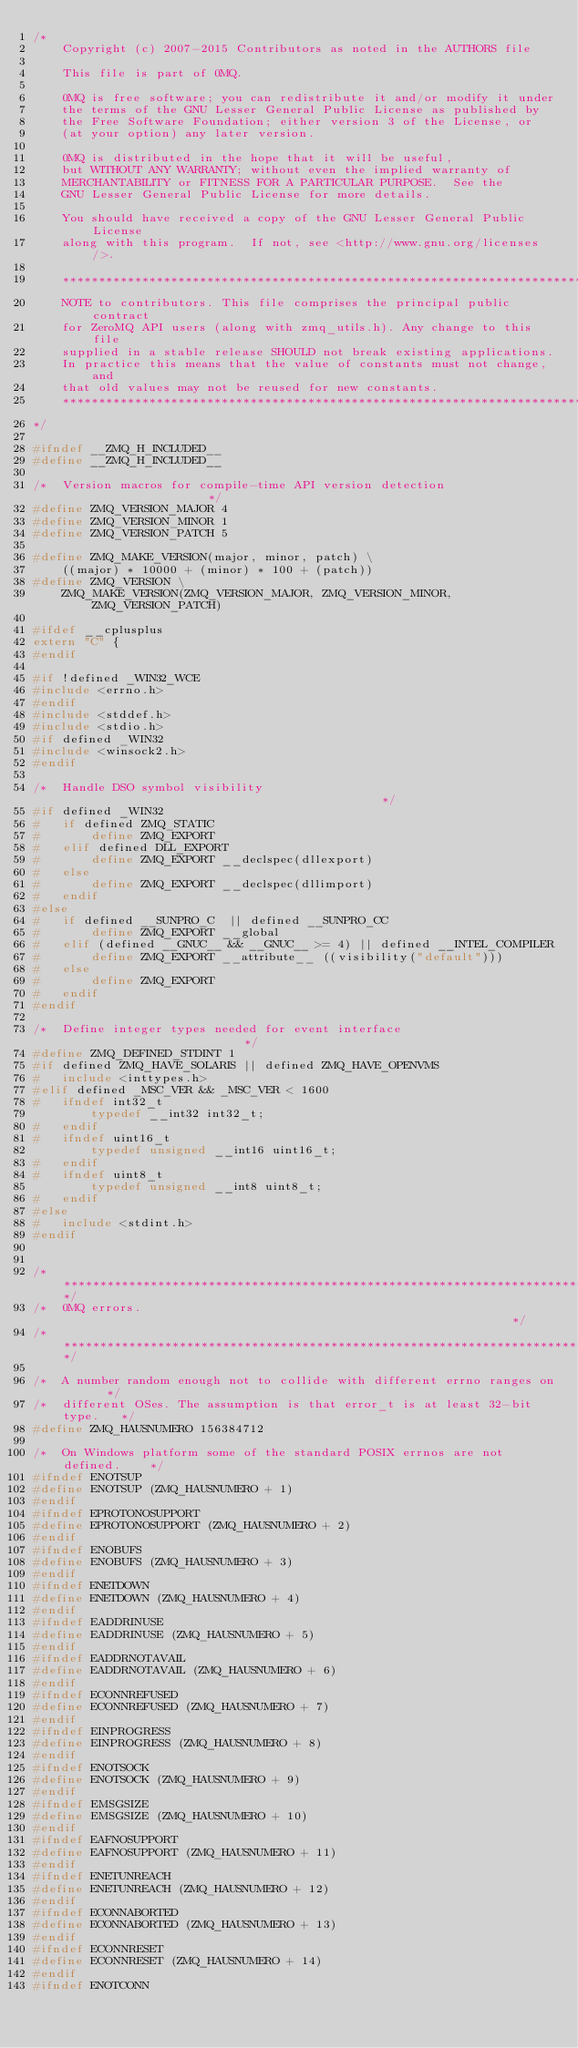Convert code to text. <code><loc_0><loc_0><loc_500><loc_500><_C_>/*
    Copyright (c) 2007-2015 Contributors as noted in the AUTHORS file

    This file is part of 0MQ.

    0MQ is free software; you can redistribute it and/or modify it under
    the terms of the GNU Lesser General Public License as published by
    the Free Software Foundation; either version 3 of the License, or
    (at your option) any later version.

    0MQ is distributed in the hope that it will be useful,
    but WITHOUT ANY WARRANTY; without even the implied warranty of
    MERCHANTABILITY or FITNESS FOR A PARTICULAR PURPOSE.  See the
    GNU Lesser General Public License for more details.

    You should have received a copy of the GNU Lesser General Public License
    along with this program.  If not, see <http://www.gnu.org/licenses/>.

    *************************************************************************
    NOTE to contributors. This file comprises the principal public contract
    for ZeroMQ API users (along with zmq_utils.h). Any change to this file
    supplied in a stable release SHOULD not break existing applications.
    In practice this means that the value of constants must not change, and
    that old values may not be reused for new constants.
    *************************************************************************
*/

#ifndef __ZMQ_H_INCLUDED__
#define __ZMQ_H_INCLUDED__

/*  Version macros for compile-time API version detection                     */
#define ZMQ_VERSION_MAJOR 4
#define ZMQ_VERSION_MINOR 1
#define ZMQ_VERSION_PATCH 5

#define ZMQ_MAKE_VERSION(major, minor, patch) \
    ((major) * 10000 + (minor) * 100 + (patch))
#define ZMQ_VERSION \
    ZMQ_MAKE_VERSION(ZMQ_VERSION_MAJOR, ZMQ_VERSION_MINOR, ZMQ_VERSION_PATCH)

#ifdef __cplusplus
extern "C" {
#endif

#if !defined _WIN32_WCE
#include <errno.h>
#endif
#include <stddef.h>
#include <stdio.h>
#if defined _WIN32
#include <winsock2.h>
#endif

/*  Handle DSO symbol visibility                                             */
#if defined _WIN32
#   if defined ZMQ_STATIC
#       define ZMQ_EXPORT
#   elif defined DLL_EXPORT
#       define ZMQ_EXPORT __declspec(dllexport)
#   else
#       define ZMQ_EXPORT __declspec(dllimport)
#   endif
#else
#   if defined __SUNPRO_C  || defined __SUNPRO_CC
#       define ZMQ_EXPORT __global
#   elif (defined __GNUC__ && __GNUC__ >= 4) || defined __INTEL_COMPILER
#       define ZMQ_EXPORT __attribute__ ((visibility("default")))
#   else
#       define ZMQ_EXPORT
#   endif
#endif

/*  Define integer types needed for event interface                          */
#define ZMQ_DEFINED_STDINT 1
#if defined ZMQ_HAVE_SOLARIS || defined ZMQ_HAVE_OPENVMS
#   include <inttypes.h>
#elif defined _MSC_VER && _MSC_VER < 1600
#   ifndef int32_t
        typedef __int32 int32_t;
#   endif
#   ifndef uint16_t
        typedef unsigned __int16 uint16_t;
#   endif
#   ifndef uint8_t
        typedef unsigned __int8 uint8_t;
#   endif
#else
#   include <stdint.h>
#endif


/******************************************************************************/
/*  0MQ errors.                                                               */
/******************************************************************************/

/*  A number random enough not to collide with different errno ranges on      */
/*  different OSes. The assumption is that error_t is at least 32-bit type.   */
#define ZMQ_HAUSNUMERO 156384712

/*  On Windows platform some of the standard POSIX errnos are not defined.    */
#ifndef ENOTSUP
#define ENOTSUP (ZMQ_HAUSNUMERO + 1)
#endif
#ifndef EPROTONOSUPPORT
#define EPROTONOSUPPORT (ZMQ_HAUSNUMERO + 2)
#endif
#ifndef ENOBUFS
#define ENOBUFS (ZMQ_HAUSNUMERO + 3)
#endif
#ifndef ENETDOWN
#define ENETDOWN (ZMQ_HAUSNUMERO + 4)
#endif
#ifndef EADDRINUSE
#define EADDRINUSE (ZMQ_HAUSNUMERO + 5)
#endif
#ifndef EADDRNOTAVAIL
#define EADDRNOTAVAIL (ZMQ_HAUSNUMERO + 6)
#endif
#ifndef ECONNREFUSED
#define ECONNREFUSED (ZMQ_HAUSNUMERO + 7)
#endif
#ifndef EINPROGRESS
#define EINPROGRESS (ZMQ_HAUSNUMERO + 8)
#endif
#ifndef ENOTSOCK
#define ENOTSOCK (ZMQ_HAUSNUMERO + 9)
#endif
#ifndef EMSGSIZE
#define EMSGSIZE (ZMQ_HAUSNUMERO + 10)
#endif
#ifndef EAFNOSUPPORT
#define EAFNOSUPPORT (ZMQ_HAUSNUMERO + 11)
#endif
#ifndef ENETUNREACH
#define ENETUNREACH (ZMQ_HAUSNUMERO + 12)
#endif
#ifndef ECONNABORTED
#define ECONNABORTED (ZMQ_HAUSNUMERO + 13)
#endif
#ifndef ECONNRESET
#define ECONNRESET (ZMQ_HAUSNUMERO + 14)
#endif
#ifndef ENOTCONN</code> 